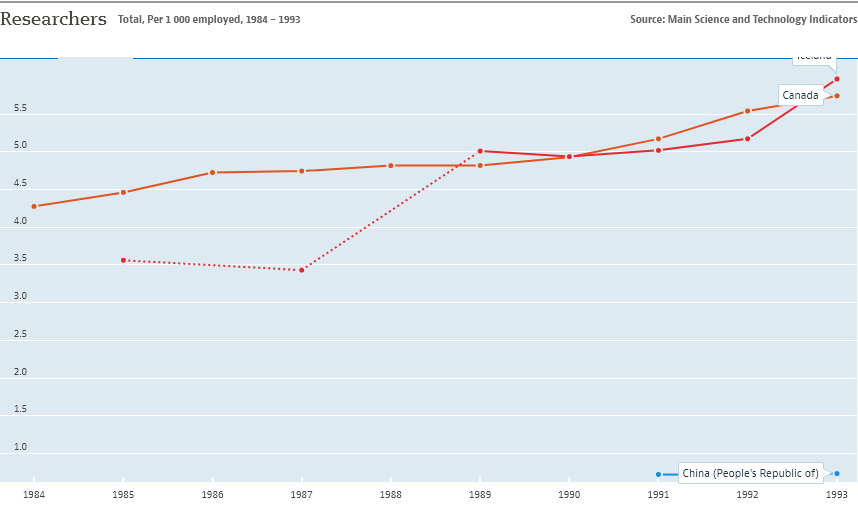Outline some significant characteristics in this image. In 1993, the year with the highest number of employed researchers in Canada was recorded. 